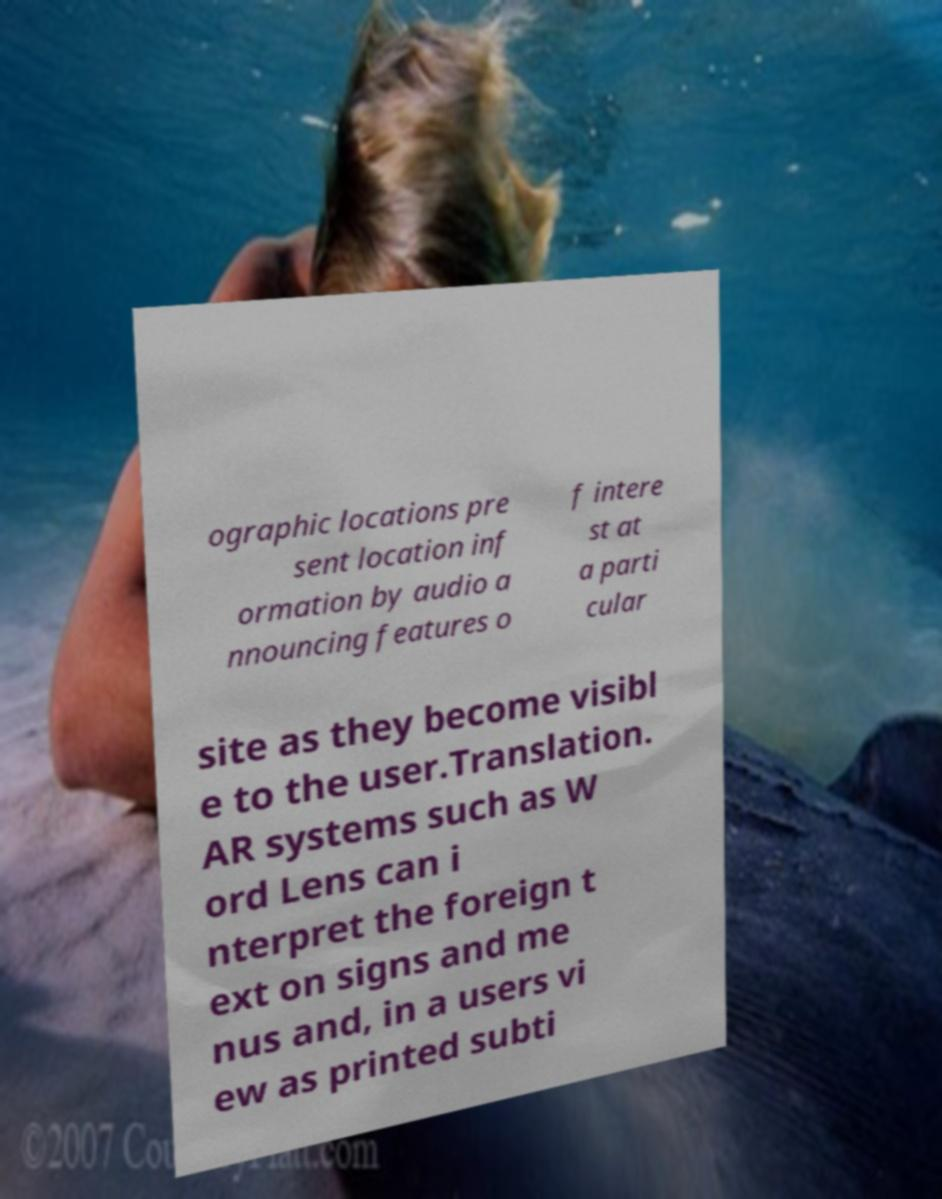Please identify and transcribe the text found in this image. ographic locations pre sent location inf ormation by audio a nnouncing features o f intere st at a parti cular site as they become visibl e to the user.Translation. AR systems such as W ord Lens can i nterpret the foreign t ext on signs and me nus and, in a users vi ew as printed subti 